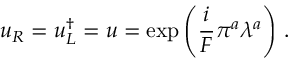<formula> <loc_0><loc_0><loc_500><loc_500>u _ { R } = u _ { L } ^ { \dagger } = u = \exp \left ( \frac { i } { F } \pi ^ { a } \lambda ^ { a } \right ) \, .</formula> 